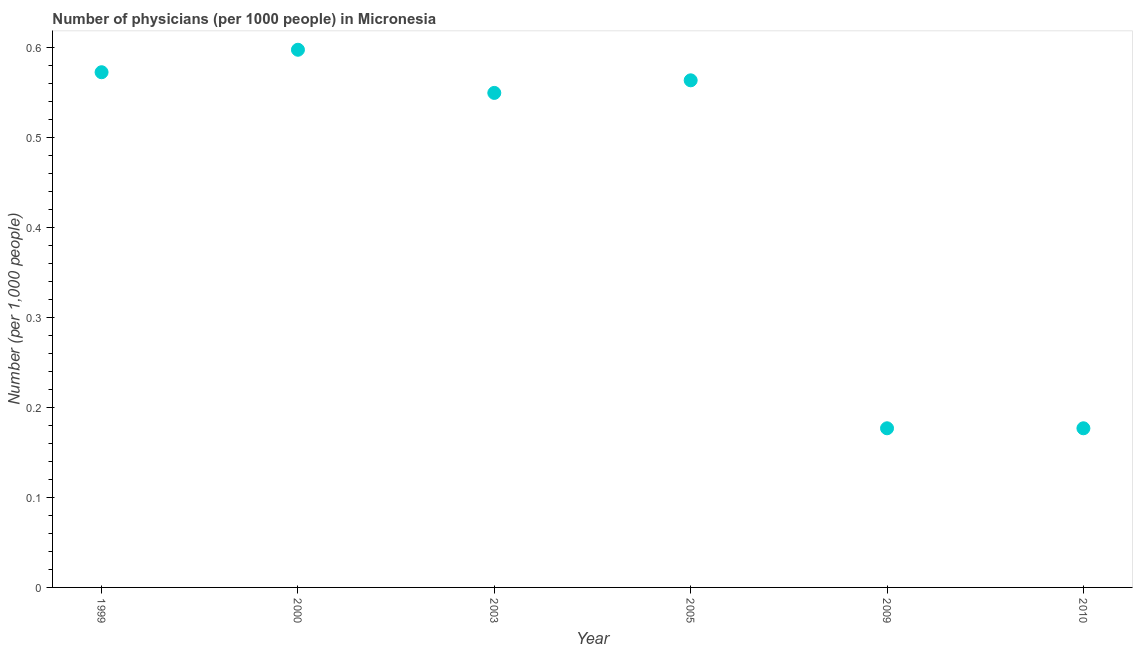What is the number of physicians in 2009?
Give a very brief answer. 0.18. Across all years, what is the maximum number of physicians?
Offer a very short reply. 0.6. Across all years, what is the minimum number of physicians?
Offer a terse response. 0.18. In which year was the number of physicians maximum?
Offer a terse response. 2000. What is the sum of the number of physicians?
Keep it short and to the point. 2.64. What is the difference between the number of physicians in 1999 and 2009?
Keep it short and to the point. 0.4. What is the average number of physicians per year?
Give a very brief answer. 0.44. What is the median number of physicians?
Offer a terse response. 0.56. What is the ratio of the number of physicians in 2005 to that in 2009?
Offer a very short reply. 3.19. Is the number of physicians in 2000 less than that in 2009?
Ensure brevity in your answer.  No. What is the difference between the highest and the second highest number of physicians?
Your answer should be very brief. 0.03. Is the sum of the number of physicians in 2000 and 2005 greater than the maximum number of physicians across all years?
Offer a very short reply. Yes. What is the difference between the highest and the lowest number of physicians?
Provide a succinct answer. 0.42. How many dotlines are there?
Your answer should be compact. 1. How many years are there in the graph?
Provide a short and direct response. 6. What is the difference between two consecutive major ticks on the Y-axis?
Give a very brief answer. 0.1. Are the values on the major ticks of Y-axis written in scientific E-notation?
Provide a succinct answer. No. Does the graph contain any zero values?
Give a very brief answer. No. Does the graph contain grids?
Your answer should be compact. No. What is the title of the graph?
Your response must be concise. Number of physicians (per 1000 people) in Micronesia. What is the label or title of the Y-axis?
Keep it short and to the point. Number (per 1,0 people). What is the Number (per 1,000 people) in 1999?
Your answer should be compact. 0.57. What is the Number (per 1,000 people) in 2000?
Offer a very short reply. 0.6. What is the Number (per 1,000 people) in 2003?
Provide a short and direct response. 0.55. What is the Number (per 1,000 people) in 2005?
Give a very brief answer. 0.56. What is the Number (per 1,000 people) in 2009?
Offer a very short reply. 0.18. What is the Number (per 1,000 people) in 2010?
Provide a succinct answer. 0.18. What is the difference between the Number (per 1,000 people) in 1999 and 2000?
Provide a short and direct response. -0.03. What is the difference between the Number (per 1,000 people) in 1999 and 2003?
Offer a very short reply. 0.02. What is the difference between the Number (per 1,000 people) in 1999 and 2005?
Make the answer very short. 0.01. What is the difference between the Number (per 1,000 people) in 1999 and 2009?
Ensure brevity in your answer.  0.4. What is the difference between the Number (per 1,000 people) in 1999 and 2010?
Provide a short and direct response. 0.4. What is the difference between the Number (per 1,000 people) in 2000 and 2003?
Make the answer very short. 0.05. What is the difference between the Number (per 1,000 people) in 2000 and 2005?
Your answer should be compact. 0.03. What is the difference between the Number (per 1,000 people) in 2000 and 2009?
Provide a short and direct response. 0.42. What is the difference between the Number (per 1,000 people) in 2000 and 2010?
Give a very brief answer. 0.42. What is the difference between the Number (per 1,000 people) in 2003 and 2005?
Offer a very short reply. -0.01. What is the difference between the Number (per 1,000 people) in 2003 and 2009?
Offer a very short reply. 0.37. What is the difference between the Number (per 1,000 people) in 2003 and 2010?
Your answer should be very brief. 0.37. What is the difference between the Number (per 1,000 people) in 2005 and 2009?
Give a very brief answer. 0.39. What is the difference between the Number (per 1,000 people) in 2005 and 2010?
Offer a very short reply. 0.39. What is the ratio of the Number (per 1,000 people) in 1999 to that in 2000?
Your answer should be very brief. 0.96. What is the ratio of the Number (per 1,000 people) in 1999 to that in 2003?
Give a very brief answer. 1.04. What is the ratio of the Number (per 1,000 people) in 1999 to that in 2005?
Your answer should be very brief. 1.02. What is the ratio of the Number (per 1,000 people) in 1999 to that in 2009?
Offer a terse response. 3.24. What is the ratio of the Number (per 1,000 people) in 1999 to that in 2010?
Your answer should be compact. 3.24. What is the ratio of the Number (per 1,000 people) in 2000 to that in 2003?
Offer a very short reply. 1.09. What is the ratio of the Number (per 1,000 people) in 2000 to that in 2005?
Your answer should be very brief. 1.06. What is the ratio of the Number (per 1,000 people) in 2000 to that in 2009?
Provide a short and direct response. 3.38. What is the ratio of the Number (per 1,000 people) in 2000 to that in 2010?
Ensure brevity in your answer.  3.38. What is the ratio of the Number (per 1,000 people) in 2003 to that in 2009?
Your response must be concise. 3.11. What is the ratio of the Number (per 1,000 people) in 2003 to that in 2010?
Your answer should be compact. 3.11. What is the ratio of the Number (per 1,000 people) in 2005 to that in 2009?
Offer a very short reply. 3.19. What is the ratio of the Number (per 1,000 people) in 2005 to that in 2010?
Offer a very short reply. 3.19. What is the ratio of the Number (per 1,000 people) in 2009 to that in 2010?
Ensure brevity in your answer.  1. 